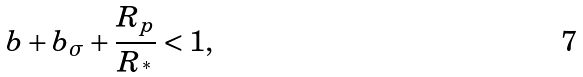<formula> <loc_0><loc_0><loc_500><loc_500>b + b _ { \sigma } + \frac { R _ { p } } { R _ { ^ { * } } } < 1 ,</formula> 